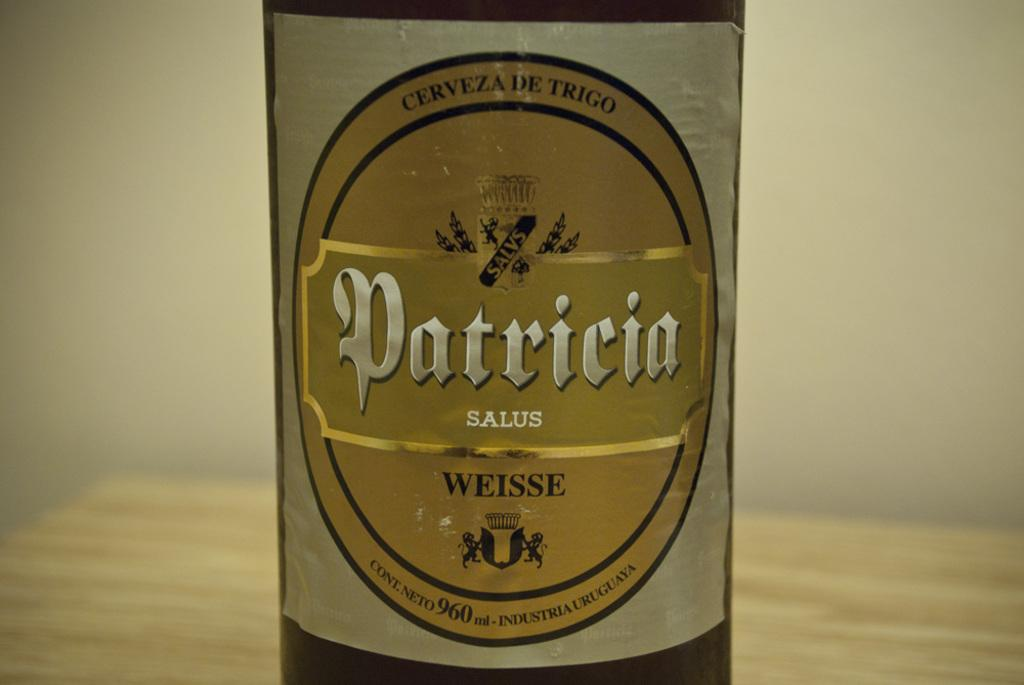<image>
Render a clear and concise summary of the photo. A bottle called Patricia sits on the table. 